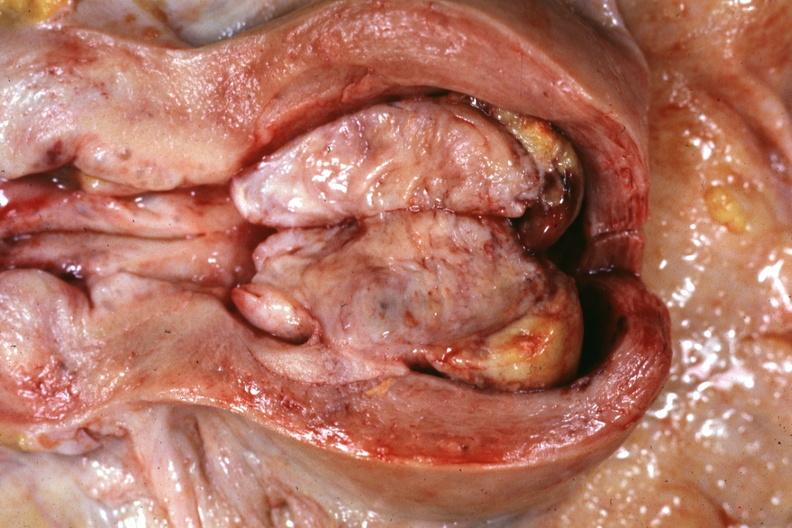s mixed mesodermal tumor present?
Answer the question using a single word or phrase. Yes 